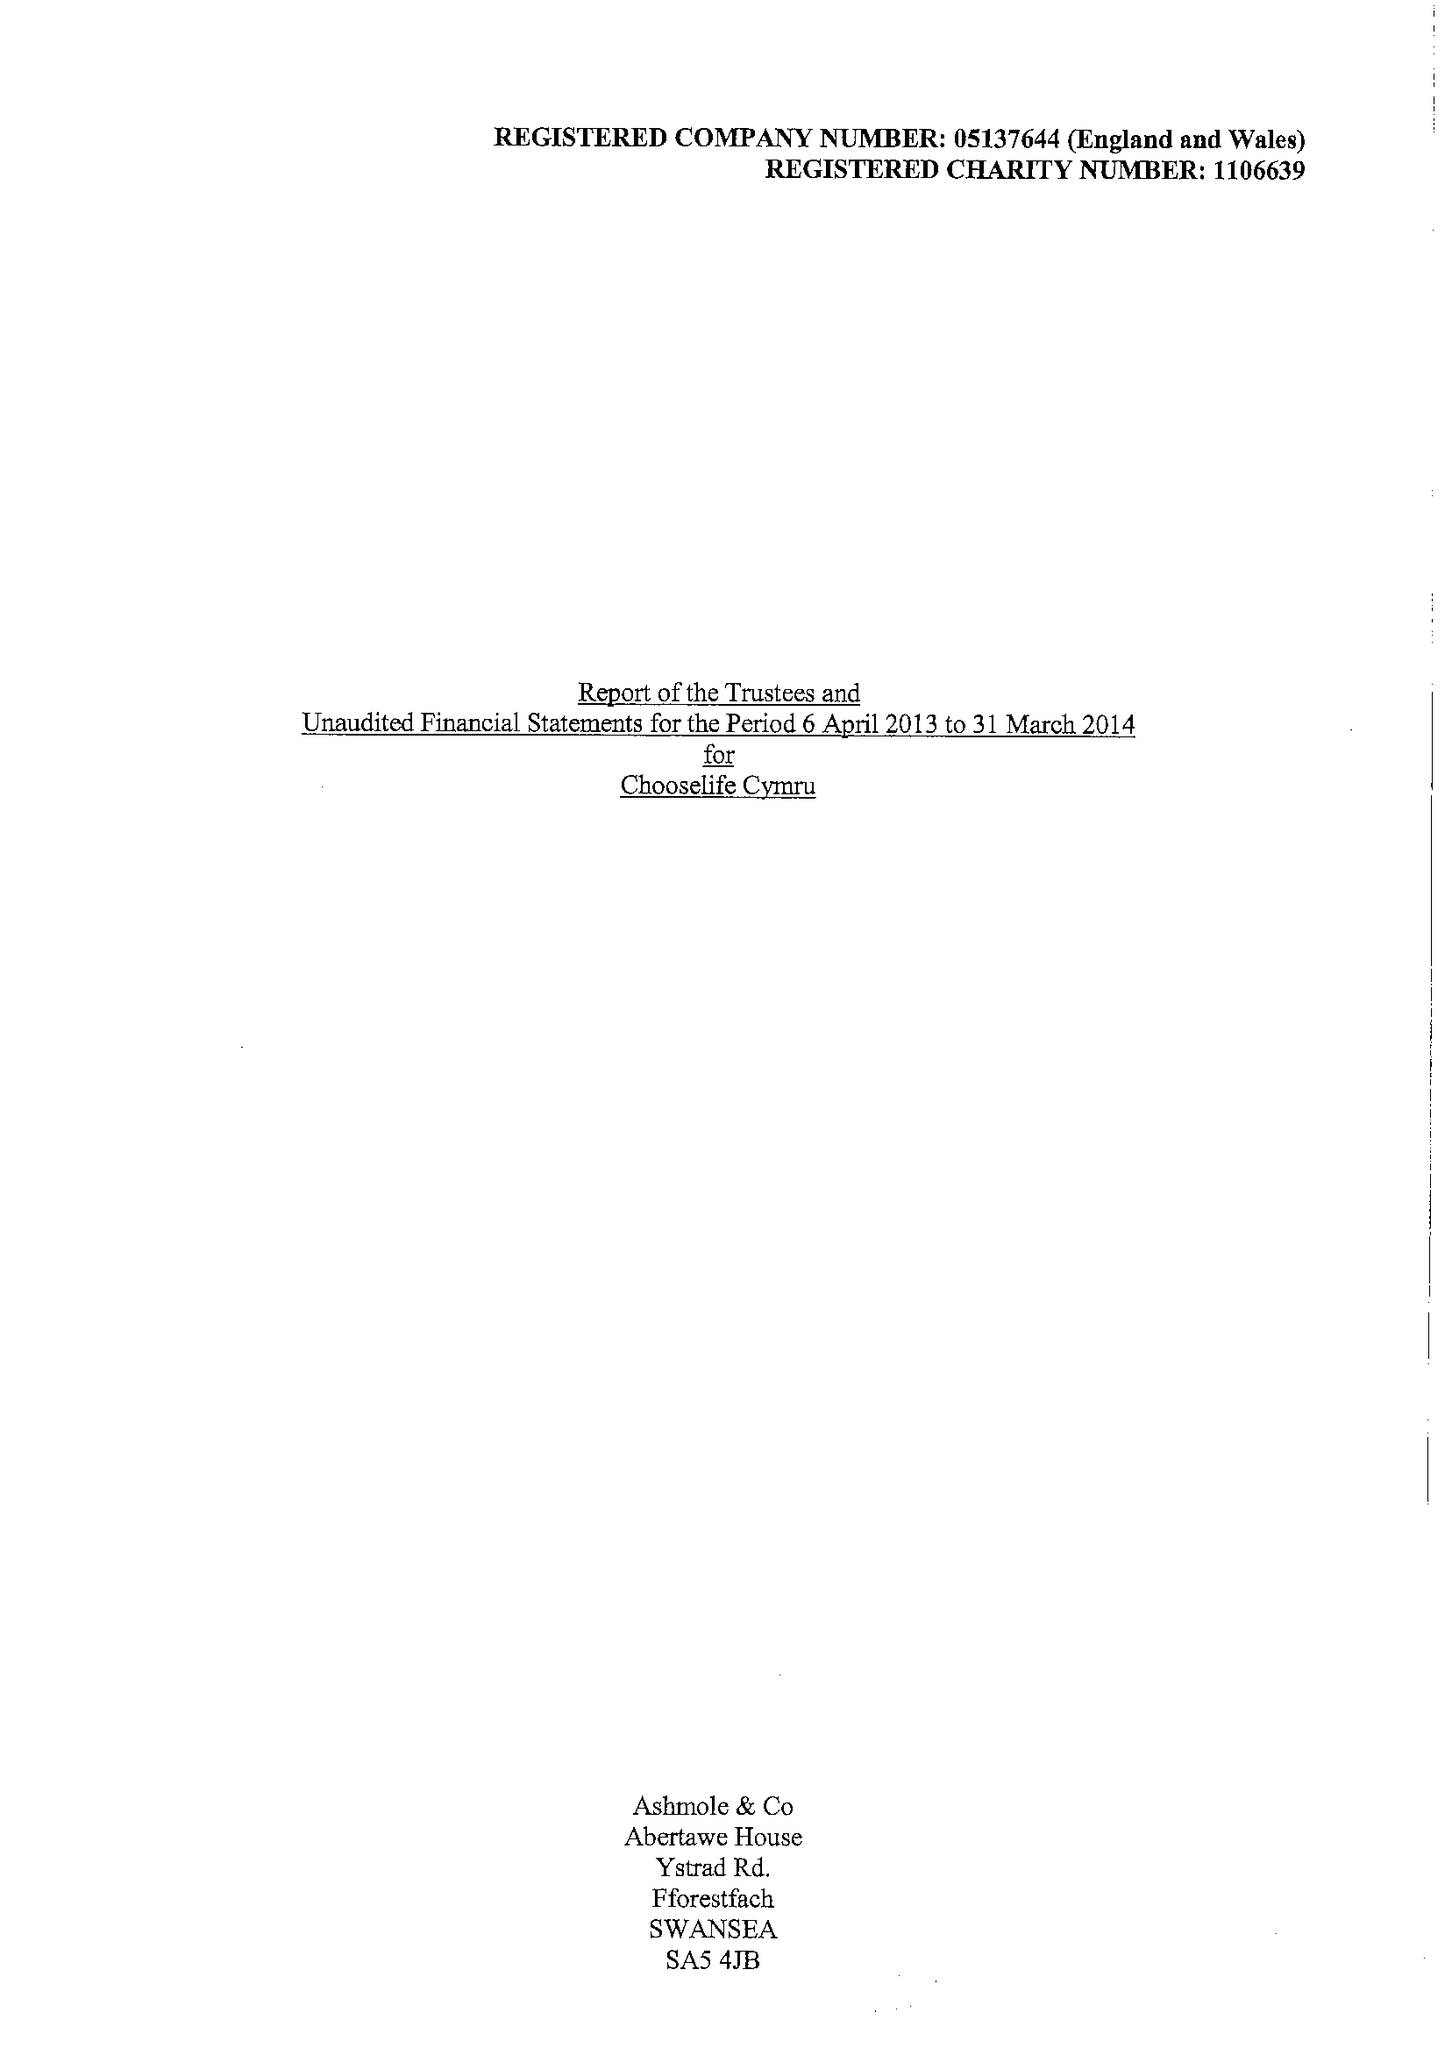What is the value for the spending_annually_in_british_pounds?
Answer the question using a single word or phrase. 366141.00 